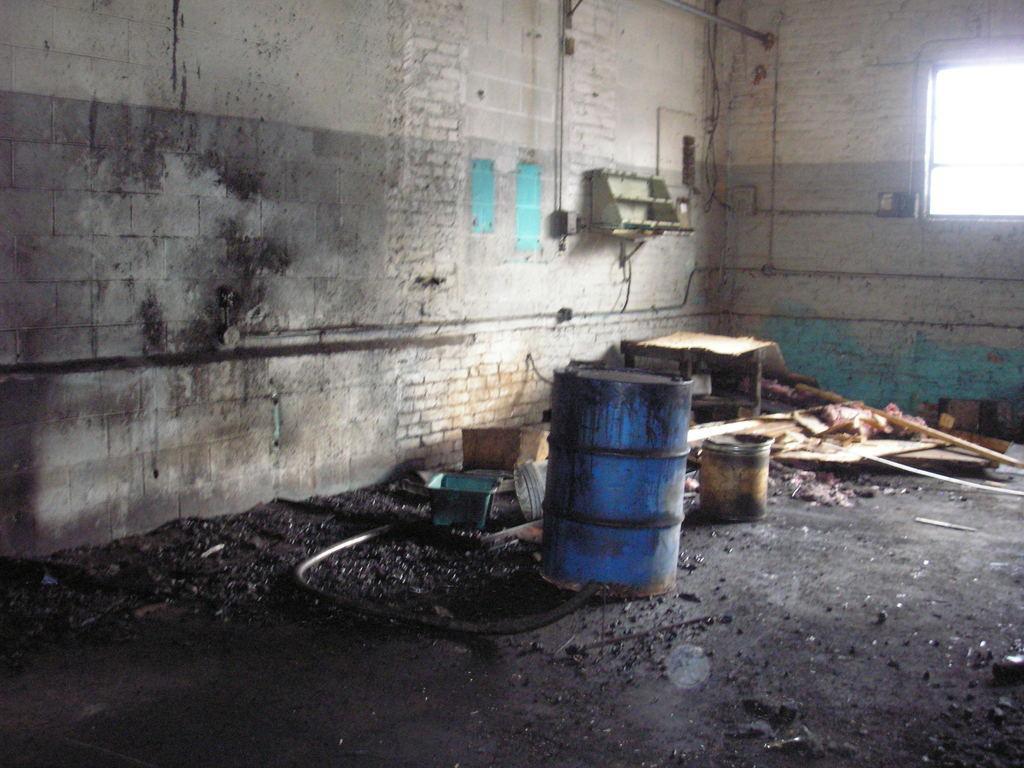How would you summarize this image in a sentence or two? In the picture I can see a water drum, a plastic bucket, water pipeline and wooden table on the ground. I can see a glass window on the top right side. I can see a metal stand on the wall and there is stainless steel pole on the top right side. 